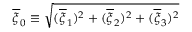<formula> <loc_0><loc_0><loc_500><loc_500>\overline { \xi } _ { 0 } \equiv \sqrt { ( \overline { \xi } _ { 1 } ) ^ { 2 } + ( \overline { \xi } _ { 2 } ) ^ { 2 } + ( \overline { \xi } _ { 3 } ) ^ { 2 } }</formula> 